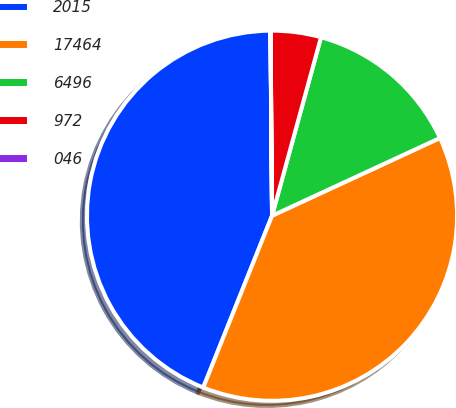Convert chart to OTSL. <chart><loc_0><loc_0><loc_500><loc_500><pie_chart><fcel>2015<fcel>17464<fcel>6496<fcel>972<fcel>046<nl><fcel>43.8%<fcel>37.96%<fcel>13.84%<fcel>4.39%<fcel>0.01%<nl></chart> 